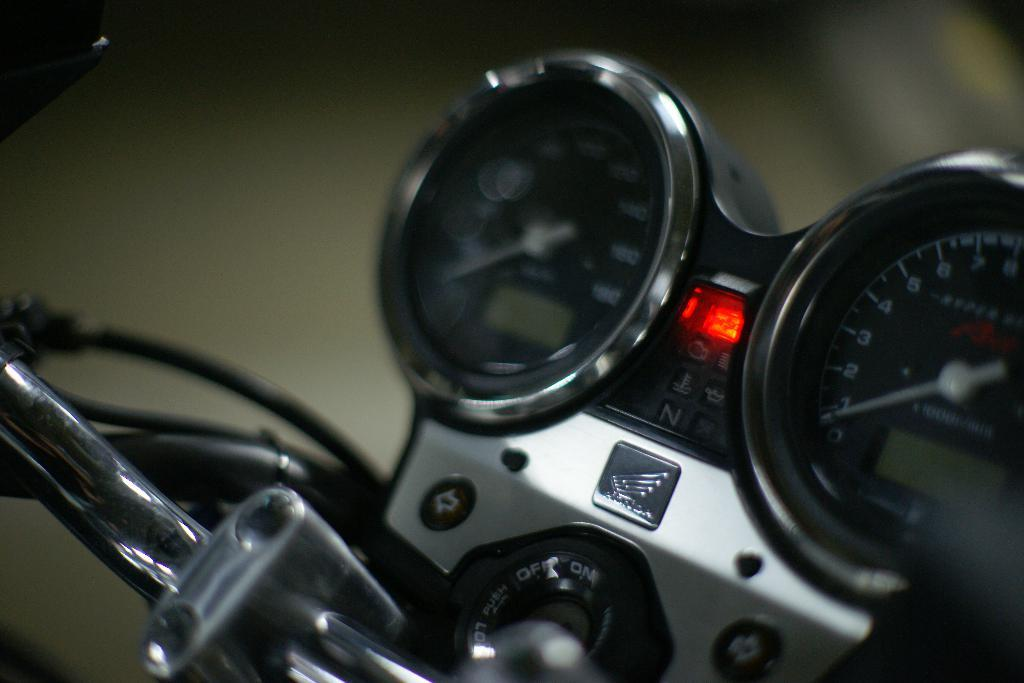What is the main subject of the image? The main subject of the image is a motorbike. What specific features can be seen on the motorbike? The motorbike has gauges. Can you describe the background of the image? The background of the image is blurred. How many bears are sitting on the motorbike in the image? There are no bears present in the image. What type of jam is being spread on the motorbike in the image? There is no jam present in the image. --- 